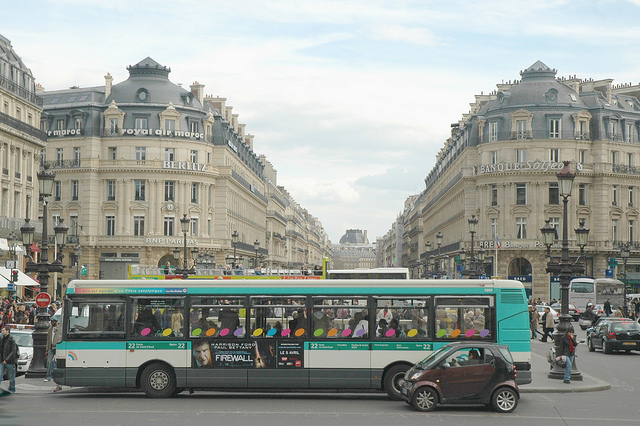Please extract the text content from this image. BERE BANQUE Solfer FIREWALL royal ARE 